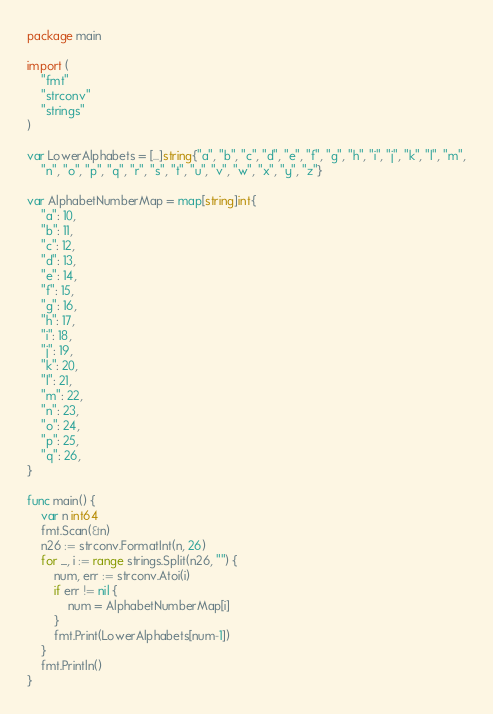Convert code to text. <code><loc_0><loc_0><loc_500><loc_500><_Go_>package main

import (
	"fmt"
	"strconv"
	"strings"
)

var LowerAlphabets = [...]string{"a", "b", "c", "d", "e", "f", "g", "h", "i", "j", "k", "l", "m",
	"n", "o", "p", "q", "r", "s", "t", "u", "v", "w", "x", "y", "z"}

var AlphabetNumberMap = map[string]int{
	"a": 10,
	"b": 11,
	"c": 12,
	"d": 13,
	"e": 14,
	"f": 15,
	"g": 16,
	"h": 17,
	"i": 18,
	"j": 19,
	"k": 20,
	"l": 21,
	"m": 22,
	"n": 23,
	"o": 24,
	"p": 25,
	"q": 26,
}

func main() {
	var n int64
	fmt.Scan(&n)
	n26 := strconv.FormatInt(n, 26)
	for _, i := range strings.Split(n26, "") {
		num, err := strconv.Atoi(i)
		if err != nil {
			num = AlphabetNumberMap[i]
		}
		fmt.Print(LowerAlphabets[num-1])
	}
	fmt.Println()
}
</code> 